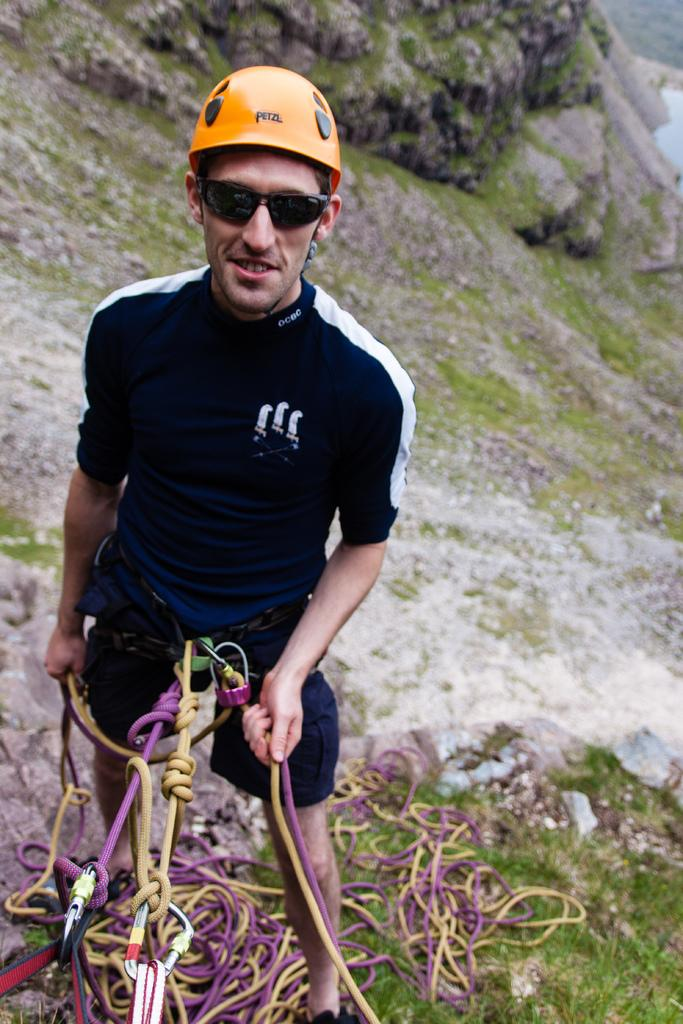Who is the person in the image? There is a man in the image. What is the man doing in the image? The man is climbing a mountain. What safety equipment is the man using while climbing? The man has ropes tied around his waist and is wearing a helmet. What protective gear is the man wearing for his eyes? The man is wearing goggles. What type of structure can be seen in the background of the image? There is no structure visible in the background of the image; it is a mountainous landscape. What type of bun is the man eating while climbing the mountain? There is no bun present in the image; the man is focused on climbing the mountain. 